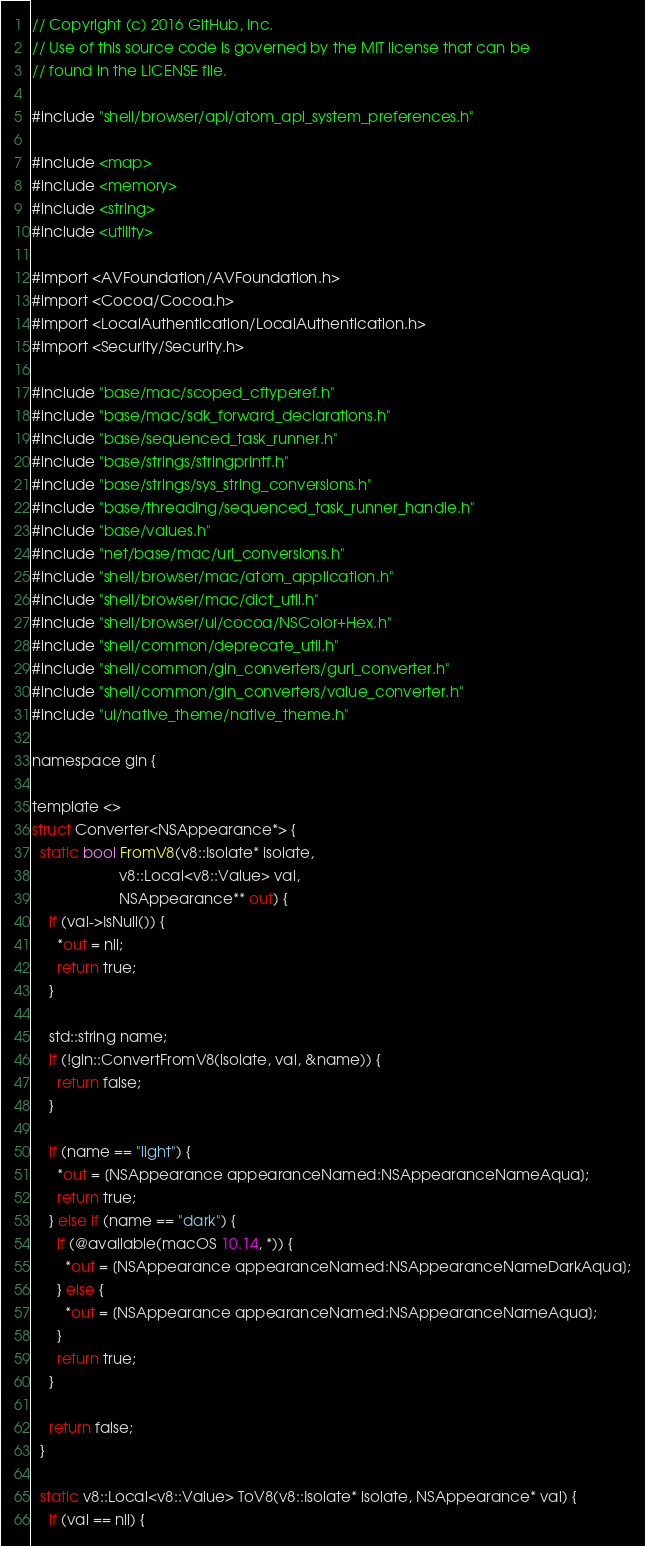<code> <loc_0><loc_0><loc_500><loc_500><_ObjectiveC_>// Copyright (c) 2016 GitHub, Inc.
// Use of this source code is governed by the MIT license that can be
// found in the LICENSE file.

#include "shell/browser/api/atom_api_system_preferences.h"

#include <map>
#include <memory>
#include <string>
#include <utility>

#import <AVFoundation/AVFoundation.h>
#import <Cocoa/Cocoa.h>
#import <LocalAuthentication/LocalAuthentication.h>
#import <Security/Security.h>

#include "base/mac/scoped_cftyperef.h"
#include "base/mac/sdk_forward_declarations.h"
#include "base/sequenced_task_runner.h"
#include "base/strings/stringprintf.h"
#include "base/strings/sys_string_conversions.h"
#include "base/threading/sequenced_task_runner_handle.h"
#include "base/values.h"
#include "net/base/mac/url_conversions.h"
#include "shell/browser/mac/atom_application.h"
#include "shell/browser/mac/dict_util.h"
#include "shell/browser/ui/cocoa/NSColor+Hex.h"
#include "shell/common/deprecate_util.h"
#include "shell/common/gin_converters/gurl_converter.h"
#include "shell/common/gin_converters/value_converter.h"
#include "ui/native_theme/native_theme.h"

namespace gin {

template <>
struct Converter<NSAppearance*> {
  static bool FromV8(v8::Isolate* isolate,
                     v8::Local<v8::Value> val,
                     NSAppearance** out) {
    if (val->IsNull()) {
      *out = nil;
      return true;
    }

    std::string name;
    if (!gin::ConvertFromV8(isolate, val, &name)) {
      return false;
    }

    if (name == "light") {
      *out = [NSAppearance appearanceNamed:NSAppearanceNameAqua];
      return true;
    } else if (name == "dark") {
      if (@available(macOS 10.14, *)) {
        *out = [NSAppearance appearanceNamed:NSAppearanceNameDarkAqua];
      } else {
        *out = [NSAppearance appearanceNamed:NSAppearanceNameAqua];
      }
      return true;
    }

    return false;
  }

  static v8::Local<v8::Value> ToV8(v8::Isolate* isolate, NSAppearance* val) {
    if (val == nil) {</code> 